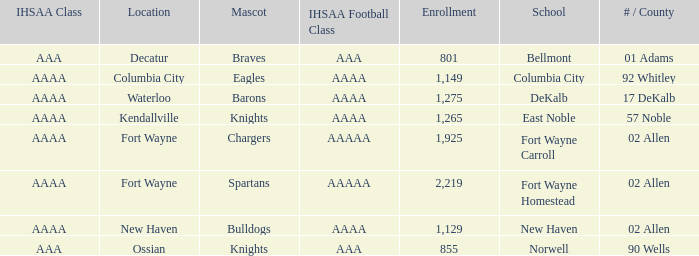What's the enrollment for Kendallville? 1265.0. 